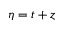Convert formula to latex. <formula><loc_0><loc_0><loc_500><loc_500>\eta = t + z</formula> 